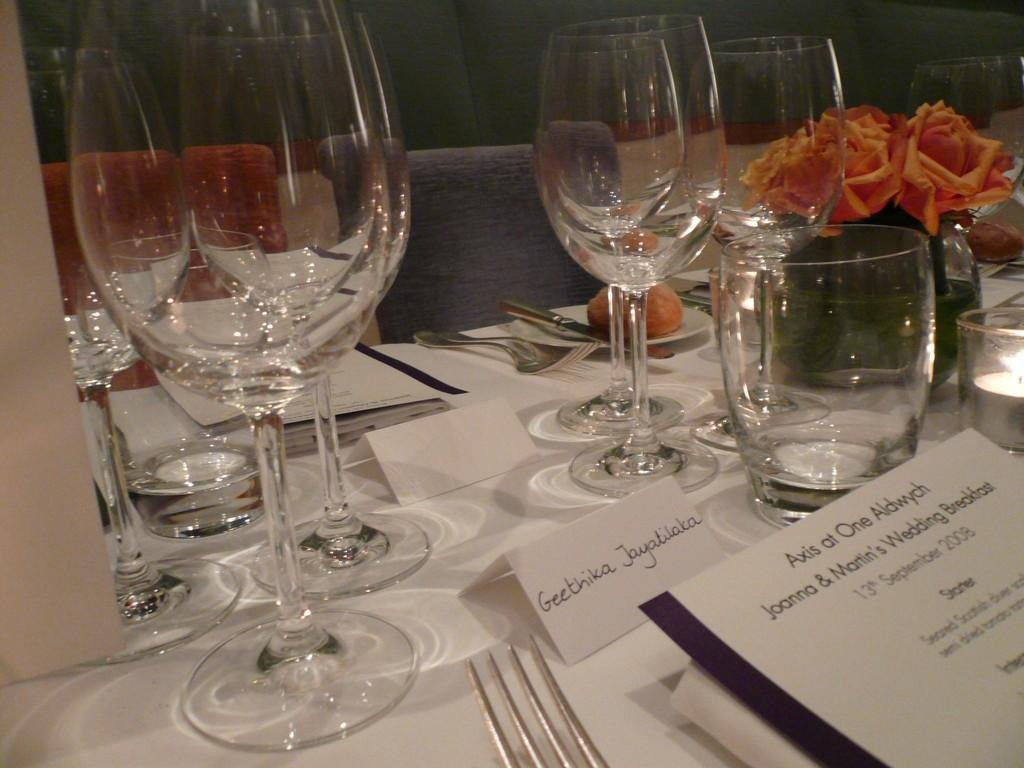What piece of furniture is present in the image? There is a table in the image. What is placed on the table? There is a glass, a flower pot, flowers, papers, spoons, and forks on the table. What can be seen inside the flower pot? There are flowers visible inside the flower pot. What is written or visible at the top of the image? There is text visible at the top of the image. How many chairs are in front of the table? There are two chairs in front of the table. Can you see your mom walking by the river with a bucket in the image? There is no reference to a mom, a river, or a bucket in the image. 